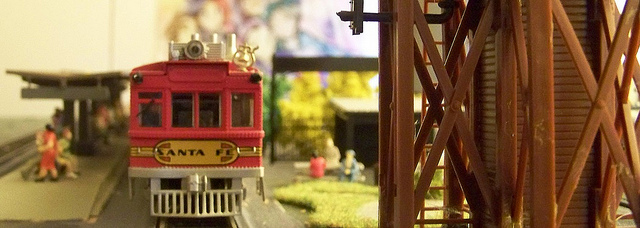Identify the text displayed in this image. ANTA 